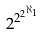<formula> <loc_0><loc_0><loc_500><loc_500>2 ^ { 2 ^ { 2 ^ { \aleph _ { 1 } } } }</formula> 